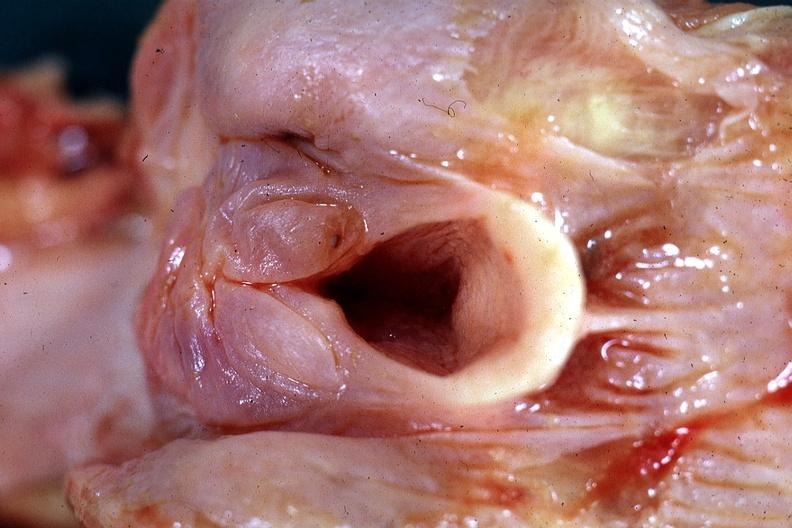what is present?
Answer the question using a single word or phrase. Pharynx 